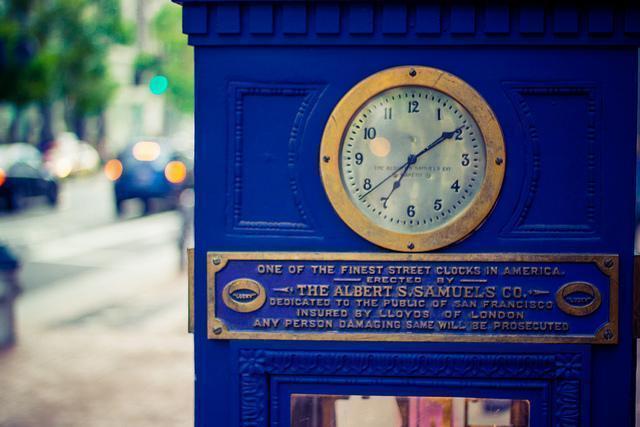In which metropolitan area is this clock installed?
Make your selection from the four choices given to correctly answer the question.
Options: Boston, san francisco, new york, london. San francisco. 